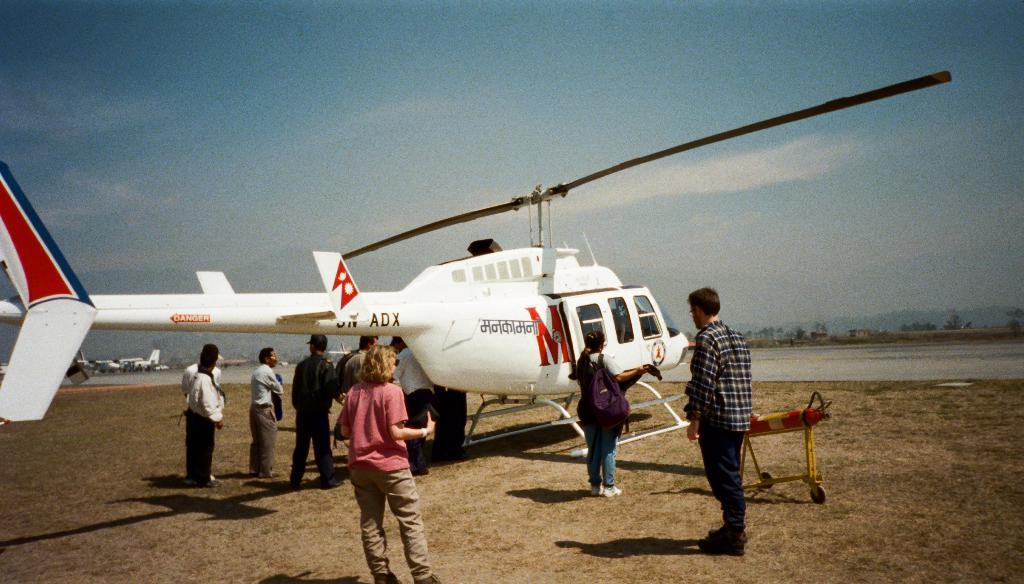Provide a one-sentence caption for the provided image. Many people are surrounding a white helicopter with a larg red M on it. 